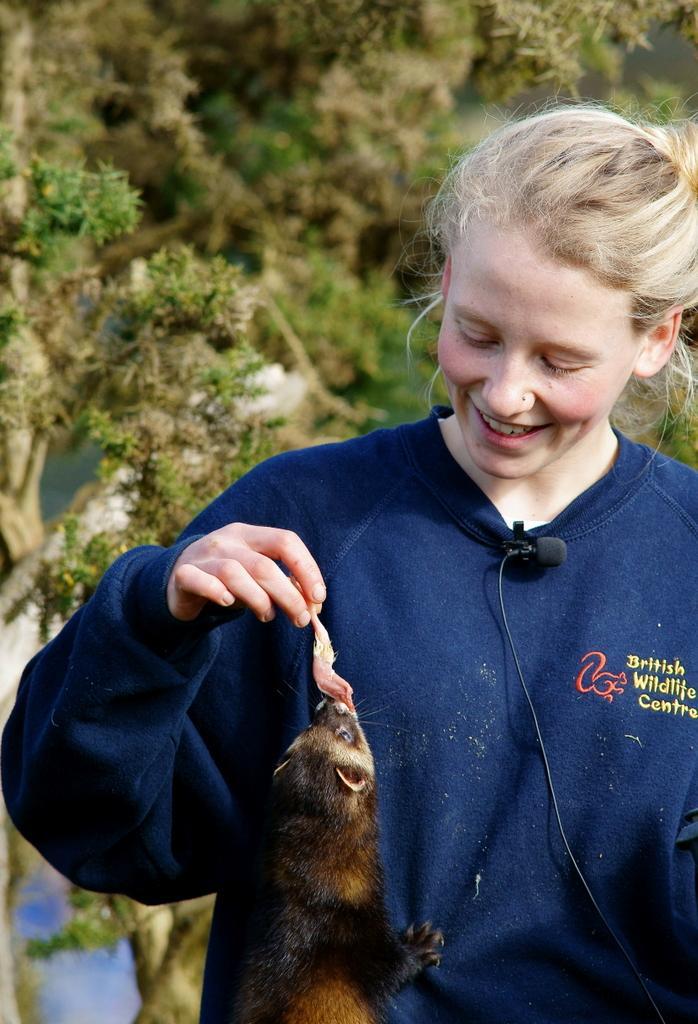Please provide a concise description of this image. Background portion of the picture is its blur. In the background we can see a tree. In this picture we can see a woman and she is holding food. We can see a microphone clip to her dress. We can see a rat. 